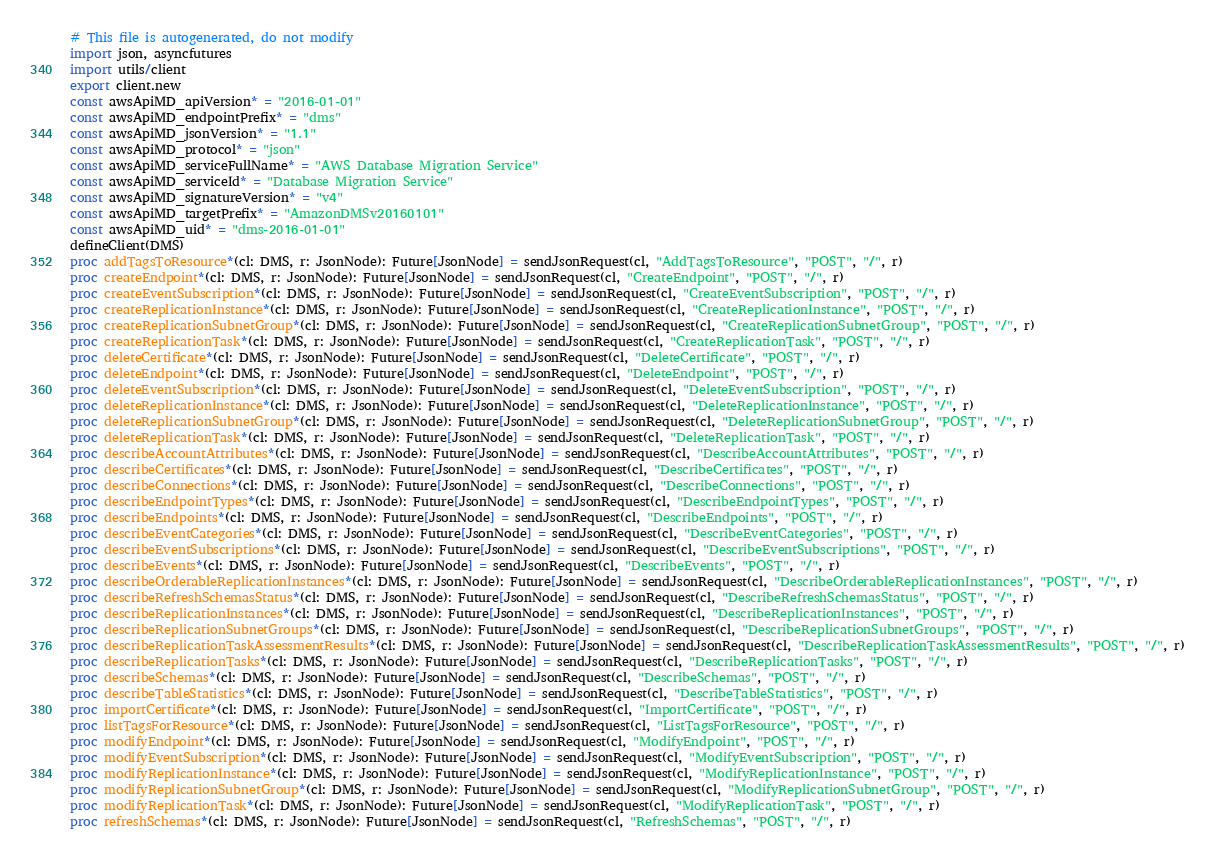Convert code to text. <code><loc_0><loc_0><loc_500><loc_500><_Nim_># This file is autogenerated, do not modify
import json, asyncfutures
import utils/client
export client.new
const awsApiMD_apiVersion* = "2016-01-01"
const awsApiMD_endpointPrefix* = "dms"
const awsApiMD_jsonVersion* = "1.1"
const awsApiMD_protocol* = "json"
const awsApiMD_serviceFullName* = "AWS Database Migration Service"
const awsApiMD_serviceId* = "Database Migration Service"
const awsApiMD_signatureVersion* = "v4"
const awsApiMD_targetPrefix* = "AmazonDMSv20160101"
const awsApiMD_uid* = "dms-2016-01-01"
defineClient(DMS)
proc addTagsToResource*(cl: DMS, r: JsonNode): Future[JsonNode] = sendJsonRequest(cl, "AddTagsToResource", "POST", "/", r)
proc createEndpoint*(cl: DMS, r: JsonNode): Future[JsonNode] = sendJsonRequest(cl, "CreateEndpoint", "POST", "/", r)
proc createEventSubscription*(cl: DMS, r: JsonNode): Future[JsonNode] = sendJsonRequest(cl, "CreateEventSubscription", "POST", "/", r)
proc createReplicationInstance*(cl: DMS, r: JsonNode): Future[JsonNode] = sendJsonRequest(cl, "CreateReplicationInstance", "POST", "/", r)
proc createReplicationSubnetGroup*(cl: DMS, r: JsonNode): Future[JsonNode] = sendJsonRequest(cl, "CreateReplicationSubnetGroup", "POST", "/", r)
proc createReplicationTask*(cl: DMS, r: JsonNode): Future[JsonNode] = sendJsonRequest(cl, "CreateReplicationTask", "POST", "/", r)
proc deleteCertificate*(cl: DMS, r: JsonNode): Future[JsonNode] = sendJsonRequest(cl, "DeleteCertificate", "POST", "/", r)
proc deleteEndpoint*(cl: DMS, r: JsonNode): Future[JsonNode] = sendJsonRequest(cl, "DeleteEndpoint", "POST", "/", r)
proc deleteEventSubscription*(cl: DMS, r: JsonNode): Future[JsonNode] = sendJsonRequest(cl, "DeleteEventSubscription", "POST", "/", r)
proc deleteReplicationInstance*(cl: DMS, r: JsonNode): Future[JsonNode] = sendJsonRequest(cl, "DeleteReplicationInstance", "POST", "/", r)
proc deleteReplicationSubnetGroup*(cl: DMS, r: JsonNode): Future[JsonNode] = sendJsonRequest(cl, "DeleteReplicationSubnetGroup", "POST", "/", r)
proc deleteReplicationTask*(cl: DMS, r: JsonNode): Future[JsonNode] = sendJsonRequest(cl, "DeleteReplicationTask", "POST", "/", r)
proc describeAccountAttributes*(cl: DMS, r: JsonNode): Future[JsonNode] = sendJsonRequest(cl, "DescribeAccountAttributes", "POST", "/", r)
proc describeCertificates*(cl: DMS, r: JsonNode): Future[JsonNode] = sendJsonRequest(cl, "DescribeCertificates", "POST", "/", r)
proc describeConnections*(cl: DMS, r: JsonNode): Future[JsonNode] = sendJsonRequest(cl, "DescribeConnections", "POST", "/", r)
proc describeEndpointTypes*(cl: DMS, r: JsonNode): Future[JsonNode] = sendJsonRequest(cl, "DescribeEndpointTypes", "POST", "/", r)
proc describeEndpoints*(cl: DMS, r: JsonNode): Future[JsonNode] = sendJsonRequest(cl, "DescribeEndpoints", "POST", "/", r)
proc describeEventCategories*(cl: DMS, r: JsonNode): Future[JsonNode] = sendJsonRequest(cl, "DescribeEventCategories", "POST", "/", r)
proc describeEventSubscriptions*(cl: DMS, r: JsonNode): Future[JsonNode] = sendJsonRequest(cl, "DescribeEventSubscriptions", "POST", "/", r)
proc describeEvents*(cl: DMS, r: JsonNode): Future[JsonNode] = sendJsonRequest(cl, "DescribeEvents", "POST", "/", r)
proc describeOrderableReplicationInstances*(cl: DMS, r: JsonNode): Future[JsonNode] = sendJsonRequest(cl, "DescribeOrderableReplicationInstances", "POST", "/", r)
proc describeRefreshSchemasStatus*(cl: DMS, r: JsonNode): Future[JsonNode] = sendJsonRequest(cl, "DescribeRefreshSchemasStatus", "POST", "/", r)
proc describeReplicationInstances*(cl: DMS, r: JsonNode): Future[JsonNode] = sendJsonRequest(cl, "DescribeReplicationInstances", "POST", "/", r)
proc describeReplicationSubnetGroups*(cl: DMS, r: JsonNode): Future[JsonNode] = sendJsonRequest(cl, "DescribeReplicationSubnetGroups", "POST", "/", r)
proc describeReplicationTaskAssessmentResults*(cl: DMS, r: JsonNode): Future[JsonNode] = sendJsonRequest(cl, "DescribeReplicationTaskAssessmentResults", "POST", "/", r)
proc describeReplicationTasks*(cl: DMS, r: JsonNode): Future[JsonNode] = sendJsonRequest(cl, "DescribeReplicationTasks", "POST", "/", r)
proc describeSchemas*(cl: DMS, r: JsonNode): Future[JsonNode] = sendJsonRequest(cl, "DescribeSchemas", "POST", "/", r)
proc describeTableStatistics*(cl: DMS, r: JsonNode): Future[JsonNode] = sendJsonRequest(cl, "DescribeTableStatistics", "POST", "/", r)
proc importCertificate*(cl: DMS, r: JsonNode): Future[JsonNode] = sendJsonRequest(cl, "ImportCertificate", "POST", "/", r)
proc listTagsForResource*(cl: DMS, r: JsonNode): Future[JsonNode] = sendJsonRequest(cl, "ListTagsForResource", "POST", "/", r)
proc modifyEndpoint*(cl: DMS, r: JsonNode): Future[JsonNode] = sendJsonRequest(cl, "ModifyEndpoint", "POST", "/", r)
proc modifyEventSubscription*(cl: DMS, r: JsonNode): Future[JsonNode] = sendJsonRequest(cl, "ModifyEventSubscription", "POST", "/", r)
proc modifyReplicationInstance*(cl: DMS, r: JsonNode): Future[JsonNode] = sendJsonRequest(cl, "ModifyReplicationInstance", "POST", "/", r)
proc modifyReplicationSubnetGroup*(cl: DMS, r: JsonNode): Future[JsonNode] = sendJsonRequest(cl, "ModifyReplicationSubnetGroup", "POST", "/", r)
proc modifyReplicationTask*(cl: DMS, r: JsonNode): Future[JsonNode] = sendJsonRequest(cl, "ModifyReplicationTask", "POST", "/", r)
proc refreshSchemas*(cl: DMS, r: JsonNode): Future[JsonNode] = sendJsonRequest(cl, "RefreshSchemas", "POST", "/", r)</code> 